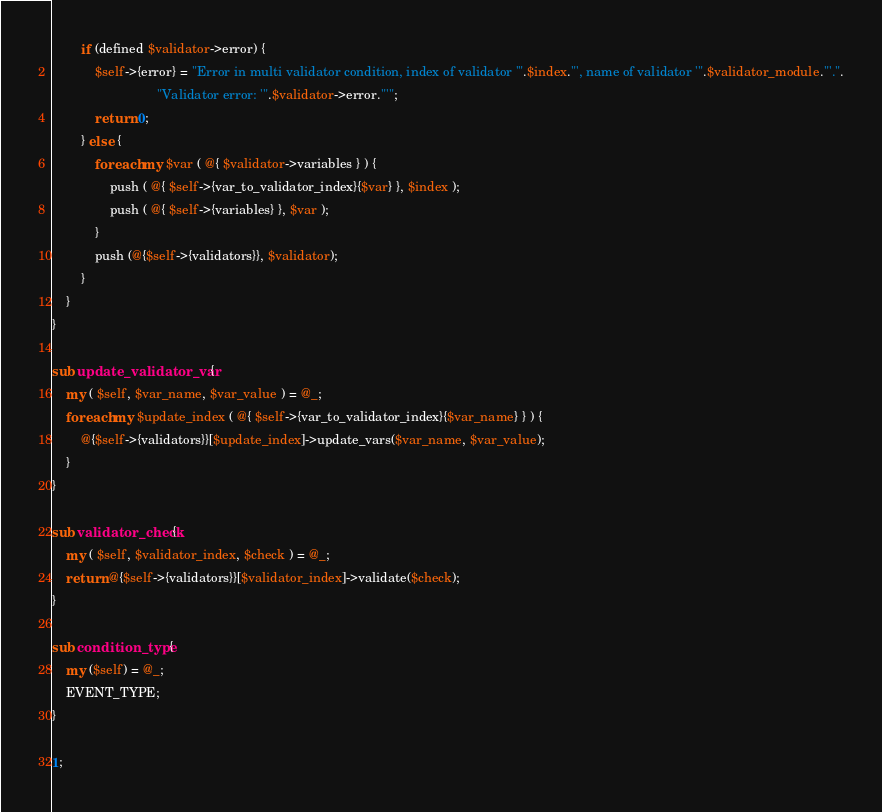Convert code to text. <code><loc_0><loc_0><loc_500><loc_500><_Perl_>		if (defined $validator->error) {
			$self->{error} = "Error in multi validator condition, index of validator '".$index."', name of validator '".$validator_module."'.".
			                 "Validator error: '".$validator->error."'";
			return 0;
		} else {
			foreach my $var ( @{ $validator->variables } ) {
				push ( @{ $self->{var_to_validator_index}{$var} }, $index );
				push ( @{ $self->{variables} }, $var );
			}
			push (@{$self->{validators}}, $validator);
		}
	}
}

sub update_validator_var {
	my ( $self, $var_name, $var_value ) = @_;
	foreach my $update_index ( @{ $self->{var_to_validator_index}{$var_name} } ) {
		@{$self->{validators}}[$update_index]->update_vars($var_name, $var_value);
	}
}

sub validator_check{
	my ( $self, $validator_index, $check ) = @_;
	return @{$self->{validators}}[$validator_index]->validate($check);
}

sub condition_type {
	my ($self) = @_;
	EVENT_TYPE;
}

1;
</code> 